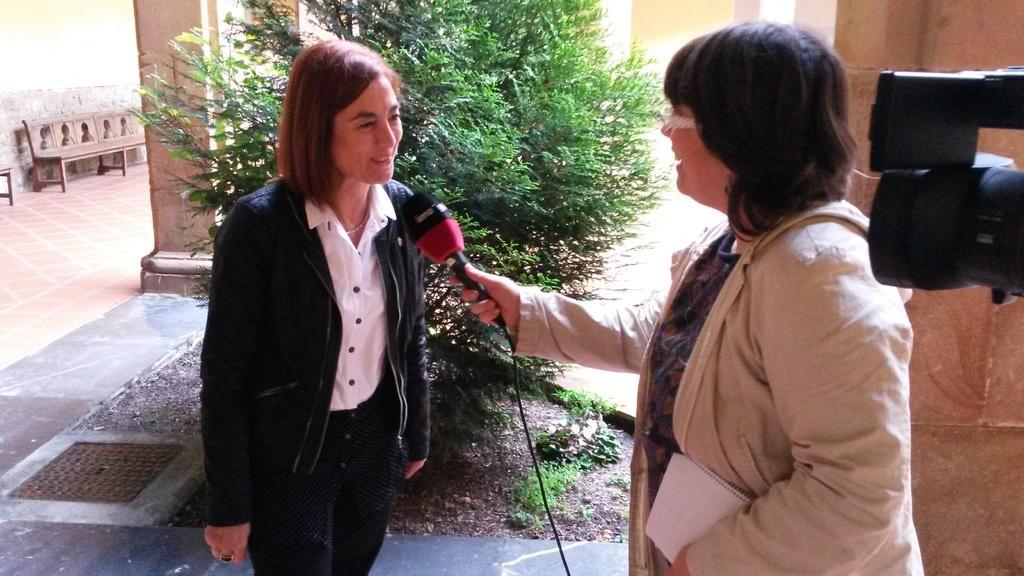Can you describe this image briefly? In this picture we can see there are two women standing on the floor. A woman is holding a microphone. On the right side of the image, there is a camera. Behind the women there is a tree, plants and pillars. On the left side of the image, there is a bench and a wall. 